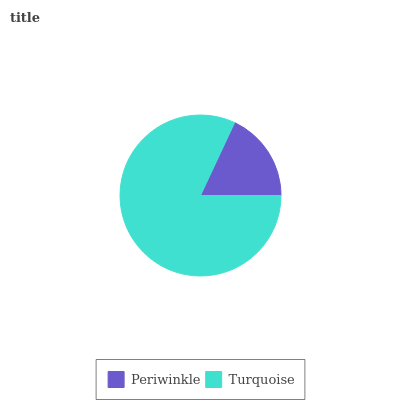Is Periwinkle the minimum?
Answer yes or no. Yes. Is Turquoise the maximum?
Answer yes or no. Yes. Is Turquoise the minimum?
Answer yes or no. No. Is Turquoise greater than Periwinkle?
Answer yes or no. Yes. Is Periwinkle less than Turquoise?
Answer yes or no. Yes. Is Periwinkle greater than Turquoise?
Answer yes or no. No. Is Turquoise less than Periwinkle?
Answer yes or no. No. Is Turquoise the high median?
Answer yes or no. Yes. Is Periwinkle the low median?
Answer yes or no. Yes. Is Periwinkle the high median?
Answer yes or no. No. Is Turquoise the low median?
Answer yes or no. No. 